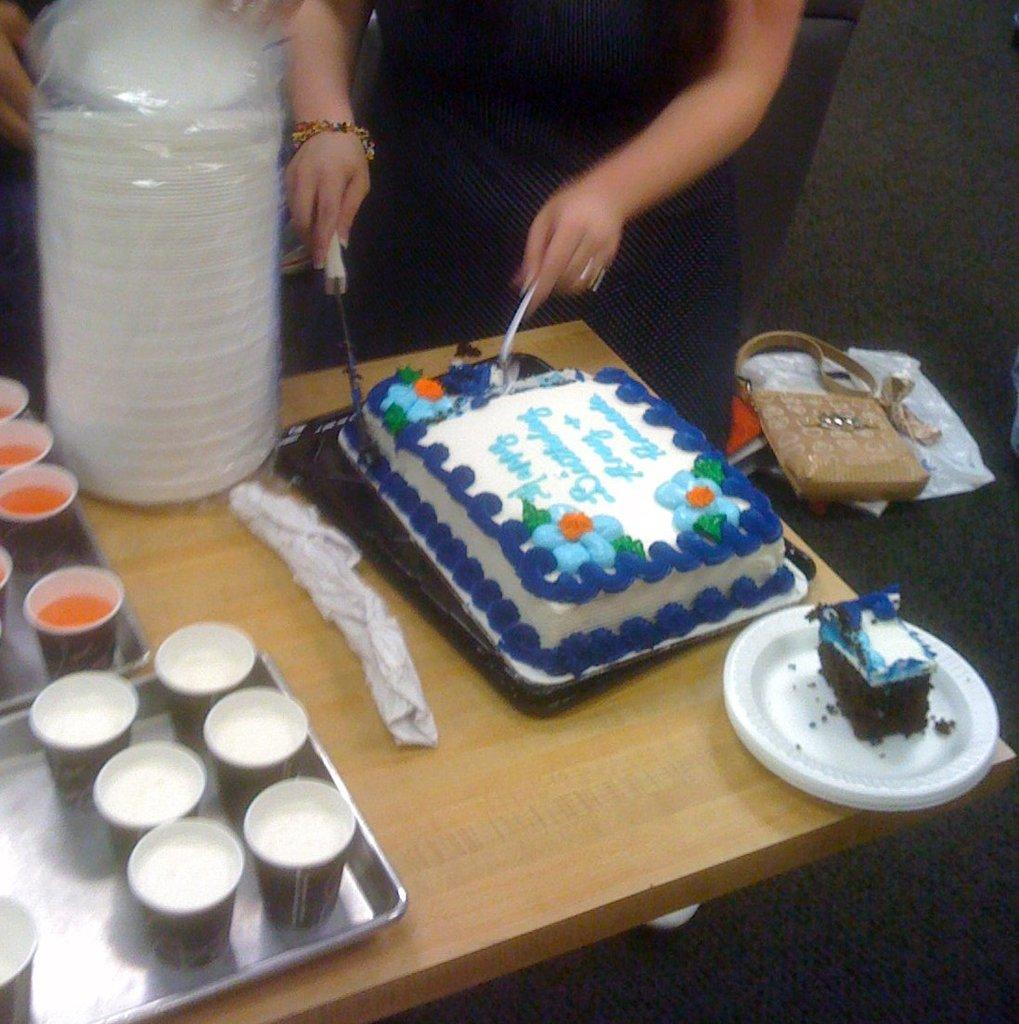What is the person in the image doing? The person is standing and cutting a cake. What is the main object being cut by the person? There is a cake in the image. What other objects are present on the table in the image? There are glasses and plates in the image. Where are all of these objects placed? All of these objects are placed on a table. What type of scale is used to weigh the cake in the image? There is no scale present in the image, and the weight of the cake is not mentioned. 